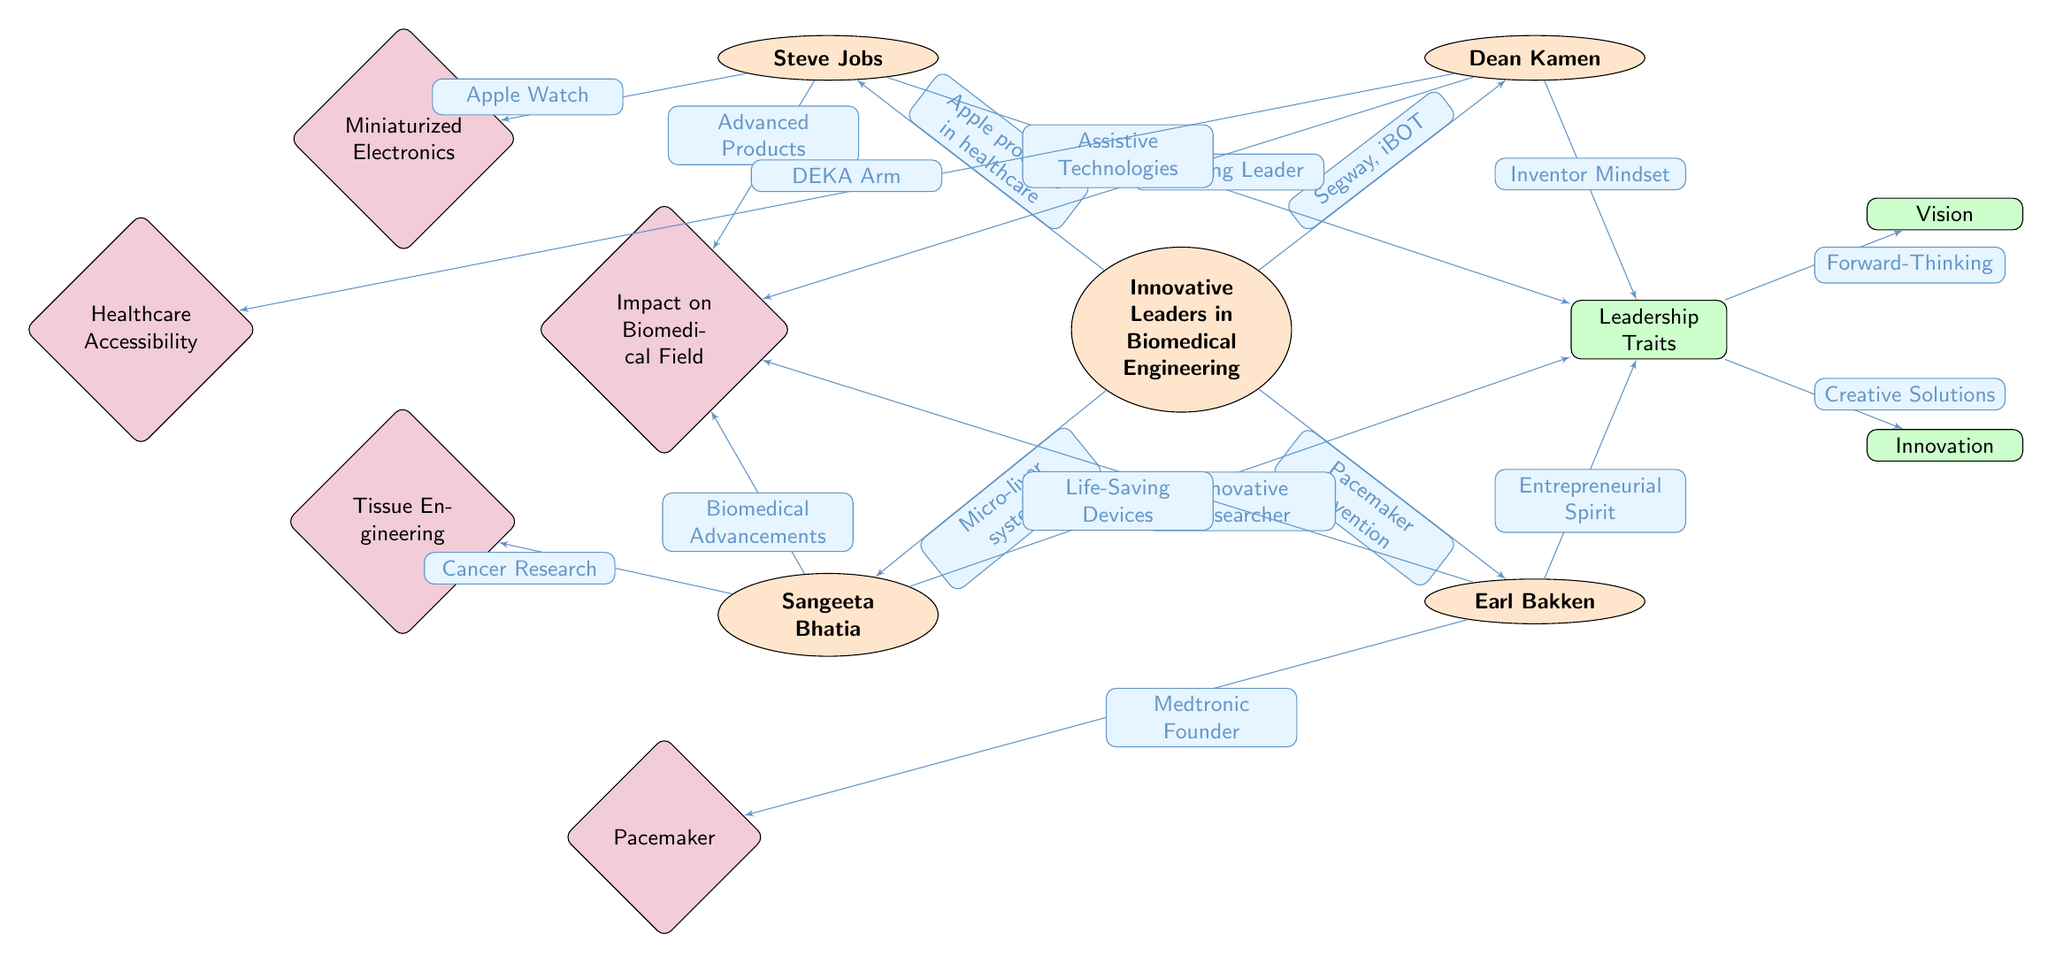What is the central node of the diagram? The central node is labeled 'Innovative Leaders in Biomedical Engineering', which represents the main theme of the diagram.
Answer: Innovative Leaders in Biomedical Engineering How many leaders are depicted in the diagram? There are four leaders in the diagram: Steve Jobs, Dean Kamen, Sangeeta Bhatia, and Earl Bakken. By counting the leader nodes, the total is found.
Answer: 4 What is one contribution associated with Steve Jobs? The contribution associated with Steve Jobs is "Apple products in healthcare," as noted on the edge connecting Jobs to the central theme.
Answer: Apple products in healthcare Which leadership trait is connected to Dean Kamen? The trait connected to Dean Kamen is "Inventor Mindset," indicated on the edge linking him to the traits node.
Answer: Inventor Mindset What impact is associated with Sangeeta Bhatia's work? The impact of Sangeeta Bhatia's work is "Biomedical Advancements," as specified on the edge leading to the impact node.
Answer: Biomedical Advancements Which innovative product is linked to the accessibility aspect of Dean Kamen's impact? The innovative product linked is the "DEKA Arm," shown on the edge connecting him to the accessibility impact node.
Answer: DEKA Arm What is the relationship between "Vision" and the central node? The relationship is that 'Vision' is a leadership trait that is connected to the central node through the "Leadership Traits" node, representing a quality of effective leadership.
Answer: Leadership Traits What contributions did Earl Bakken make to the biomedical field? Earl Bakken's contributions include the invention of the "Pacemaker," which is listed on the edge linking him to the central impact area.
Answer: Pacemaker What does the trait "Creative Solutions" indicate in the context of the diagram? "Creative Solutions" pertains to the innovative approaches associated with the central theme, specifically in how innovations in leadership lead to fresh ideas in biomedical engineering.
Answer: Creative Solutions 